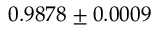<formula> <loc_0><loc_0><loc_500><loc_500>0 . 9 8 7 8 \pm 0 . 0 0 0 9</formula> 